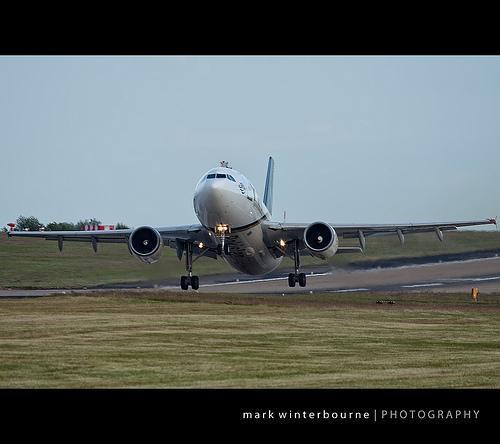How many planes are shown?
Give a very brief answer. 1. How many wings are shown?
Give a very brief answer. 2. 